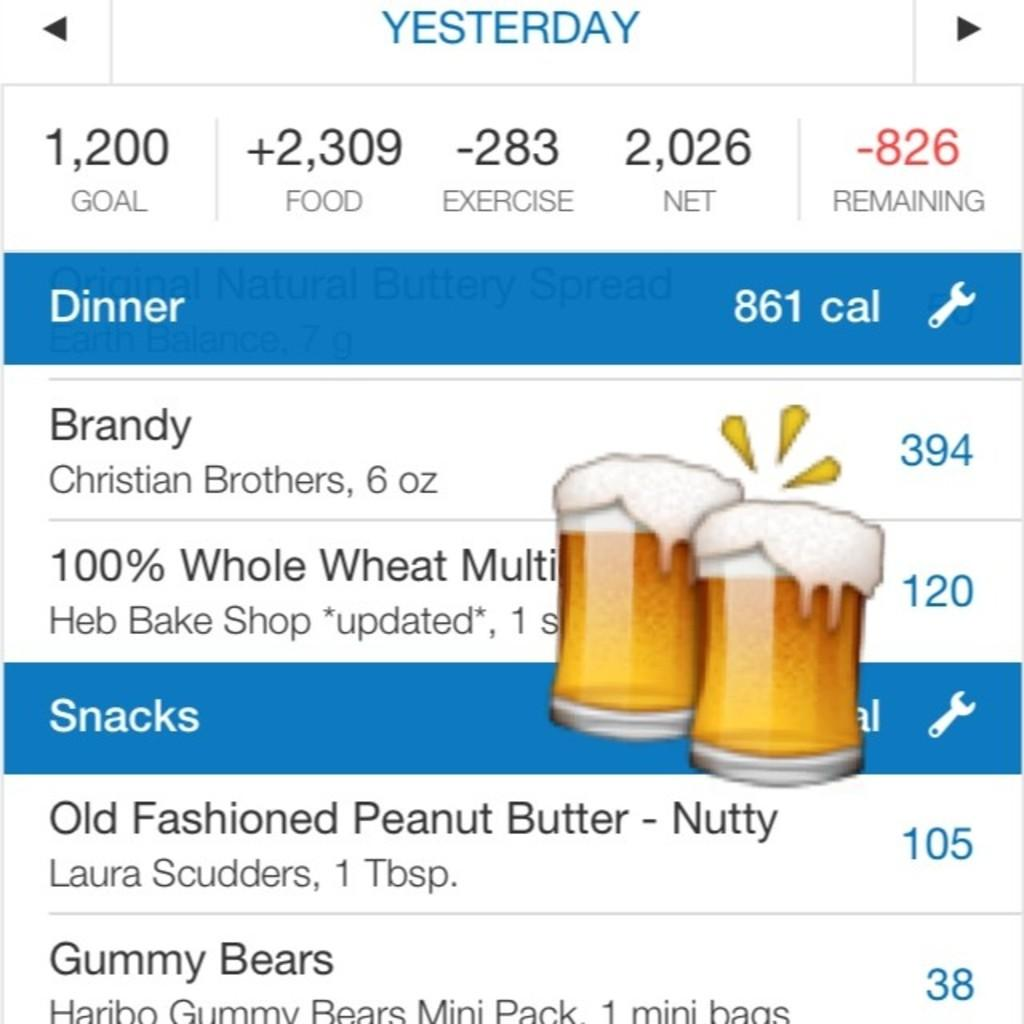What type of image is this? The image appears to be a screenshot. What can be seen in the image besides the screenshot? There is text visible in the image. Are there any symbols or icons present in the image? Yes, there is an emoji of glasses with a drink in the image. What type of cub is shown in the image? There is no cub present in the image. What rule is being enforced in the image? There is no indication of any rules being enforced in the image. Is there a jail visible in the image? There is no jail present in the image. 